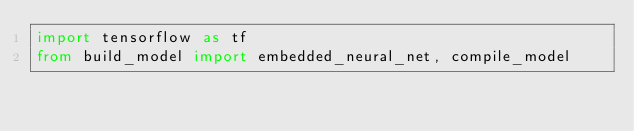Convert code to text. <code><loc_0><loc_0><loc_500><loc_500><_Python_>import tensorflow as tf
from build_model import embedded_neural_net, compile_model

</code> 